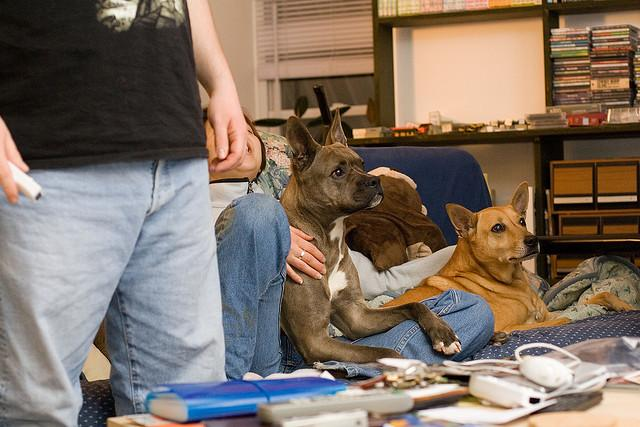Where are these people located? Please explain your reasoning. home. They look to be in a house and in someones living room. 